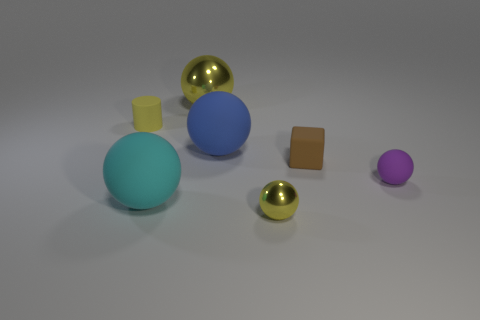Subtract all purple balls. How many balls are left? 4 Subtract all small purple balls. How many balls are left? 4 Subtract all gray spheres. Subtract all brown cylinders. How many spheres are left? 5 Add 2 big yellow shiny spheres. How many objects exist? 9 Subtract all balls. How many objects are left? 2 Add 4 tiny yellow rubber cylinders. How many tiny yellow rubber cylinders are left? 5 Add 7 large blue objects. How many large blue objects exist? 8 Subtract 0 purple cubes. How many objects are left? 7 Subtract all tiny yellow cylinders. Subtract all green rubber things. How many objects are left? 6 